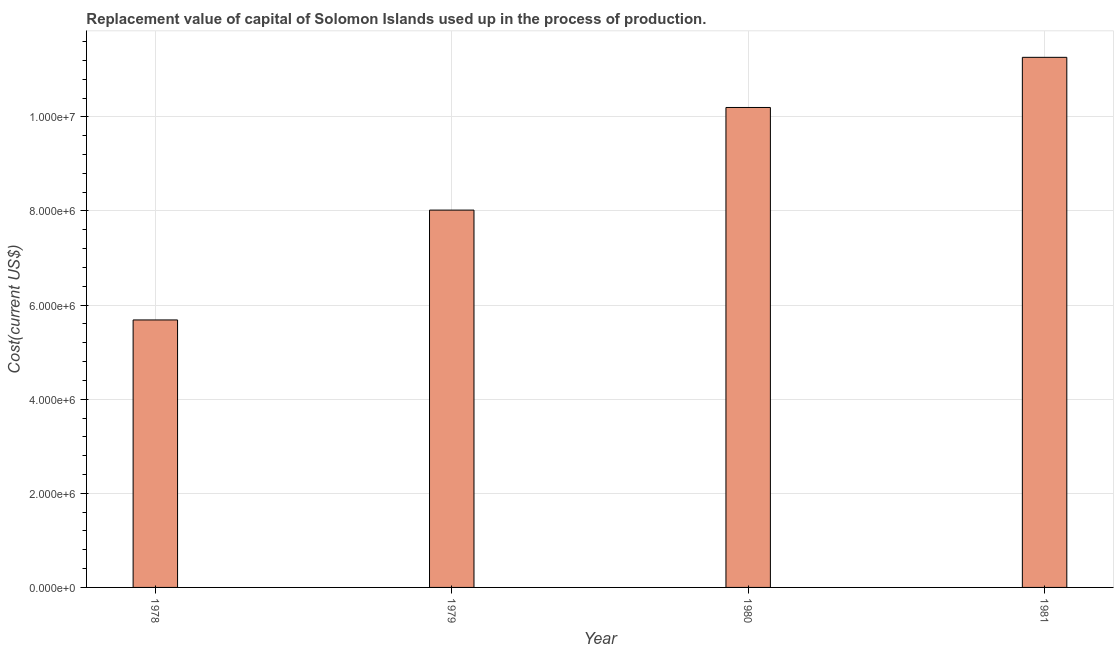Does the graph contain grids?
Your response must be concise. Yes. What is the title of the graph?
Your answer should be compact. Replacement value of capital of Solomon Islands used up in the process of production. What is the label or title of the X-axis?
Ensure brevity in your answer.  Year. What is the label or title of the Y-axis?
Provide a short and direct response. Cost(current US$). What is the consumption of fixed capital in 1981?
Ensure brevity in your answer.  1.13e+07. Across all years, what is the maximum consumption of fixed capital?
Provide a short and direct response. 1.13e+07. Across all years, what is the minimum consumption of fixed capital?
Provide a short and direct response. 5.68e+06. In which year was the consumption of fixed capital maximum?
Offer a terse response. 1981. In which year was the consumption of fixed capital minimum?
Provide a succinct answer. 1978. What is the sum of the consumption of fixed capital?
Keep it short and to the point. 3.52e+07. What is the difference between the consumption of fixed capital in 1979 and 1981?
Ensure brevity in your answer.  -3.25e+06. What is the average consumption of fixed capital per year?
Your answer should be compact. 8.79e+06. What is the median consumption of fixed capital?
Your response must be concise. 9.11e+06. What is the ratio of the consumption of fixed capital in 1979 to that in 1981?
Your answer should be very brief. 0.71. Is the difference between the consumption of fixed capital in 1978 and 1979 greater than the difference between any two years?
Provide a short and direct response. No. What is the difference between the highest and the second highest consumption of fixed capital?
Give a very brief answer. 1.07e+06. What is the difference between the highest and the lowest consumption of fixed capital?
Your answer should be very brief. 5.58e+06. Are all the bars in the graph horizontal?
Ensure brevity in your answer.  No. How many years are there in the graph?
Your answer should be compact. 4. What is the difference between two consecutive major ticks on the Y-axis?
Your answer should be compact. 2.00e+06. What is the Cost(current US$) of 1978?
Give a very brief answer. 5.68e+06. What is the Cost(current US$) of 1979?
Your response must be concise. 8.02e+06. What is the Cost(current US$) in 1980?
Offer a very short reply. 1.02e+07. What is the Cost(current US$) of 1981?
Offer a very short reply. 1.13e+07. What is the difference between the Cost(current US$) in 1978 and 1979?
Offer a terse response. -2.33e+06. What is the difference between the Cost(current US$) in 1978 and 1980?
Provide a succinct answer. -4.51e+06. What is the difference between the Cost(current US$) in 1978 and 1981?
Give a very brief answer. -5.58e+06. What is the difference between the Cost(current US$) in 1979 and 1980?
Your answer should be very brief. -2.18e+06. What is the difference between the Cost(current US$) in 1979 and 1981?
Make the answer very short. -3.25e+06. What is the difference between the Cost(current US$) in 1980 and 1981?
Give a very brief answer. -1.07e+06. What is the ratio of the Cost(current US$) in 1978 to that in 1979?
Make the answer very short. 0.71. What is the ratio of the Cost(current US$) in 1978 to that in 1980?
Give a very brief answer. 0.56. What is the ratio of the Cost(current US$) in 1978 to that in 1981?
Make the answer very short. 0.51. What is the ratio of the Cost(current US$) in 1979 to that in 1980?
Ensure brevity in your answer.  0.79. What is the ratio of the Cost(current US$) in 1979 to that in 1981?
Offer a very short reply. 0.71. What is the ratio of the Cost(current US$) in 1980 to that in 1981?
Provide a short and direct response. 0.91. 